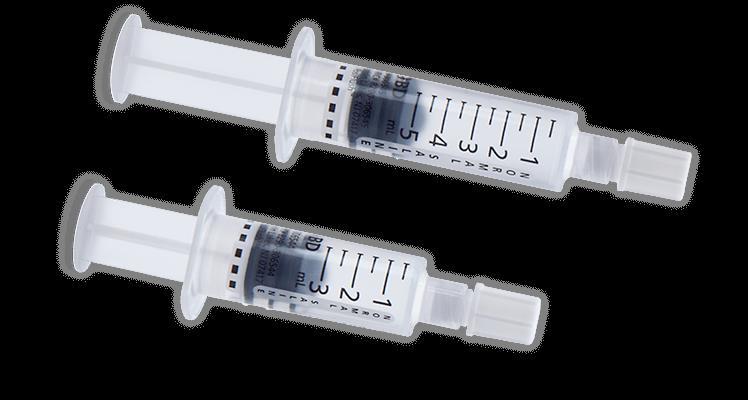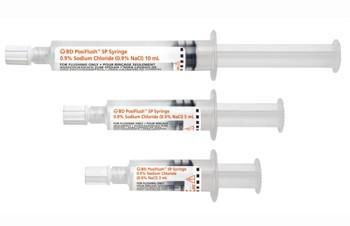The first image is the image on the left, the second image is the image on the right. Analyze the images presented: Is the assertion "The right image shows a single syringe." valid? Answer yes or no. No. 